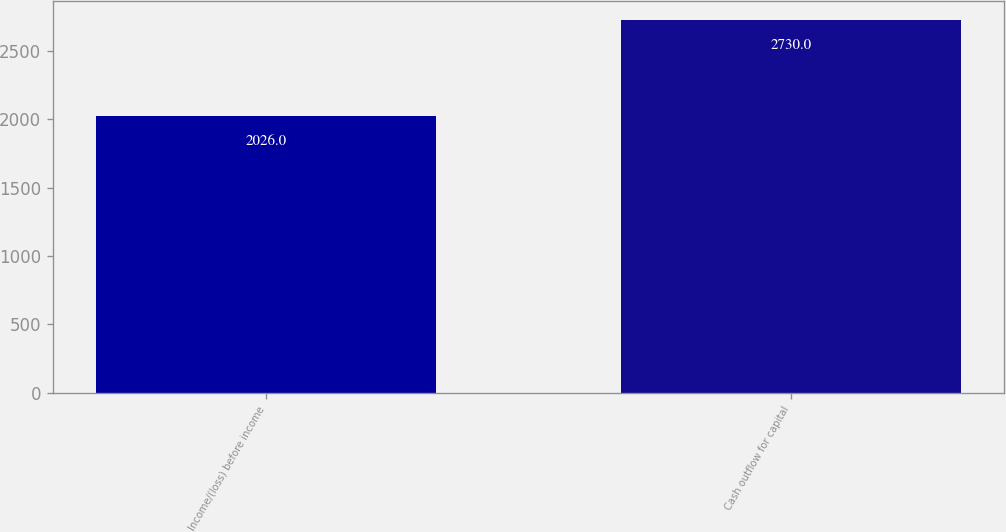Convert chart to OTSL. <chart><loc_0><loc_0><loc_500><loc_500><bar_chart><fcel>Income/(loss) before income<fcel>Cash outflow for capital<nl><fcel>2026<fcel>2730<nl></chart> 